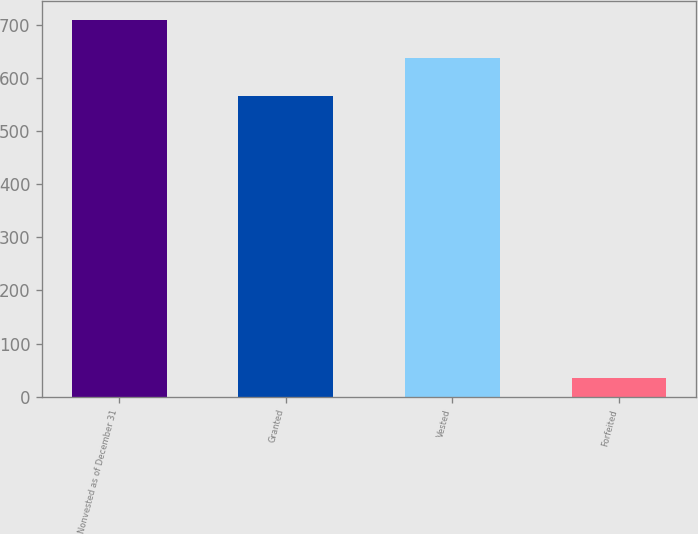Convert chart. <chart><loc_0><loc_0><loc_500><loc_500><bar_chart><fcel>Nonvested as of December 31<fcel>Granted<fcel>Vested<fcel>Forfeited<nl><fcel>710.2<fcel>566<fcel>638.1<fcel>35<nl></chart> 